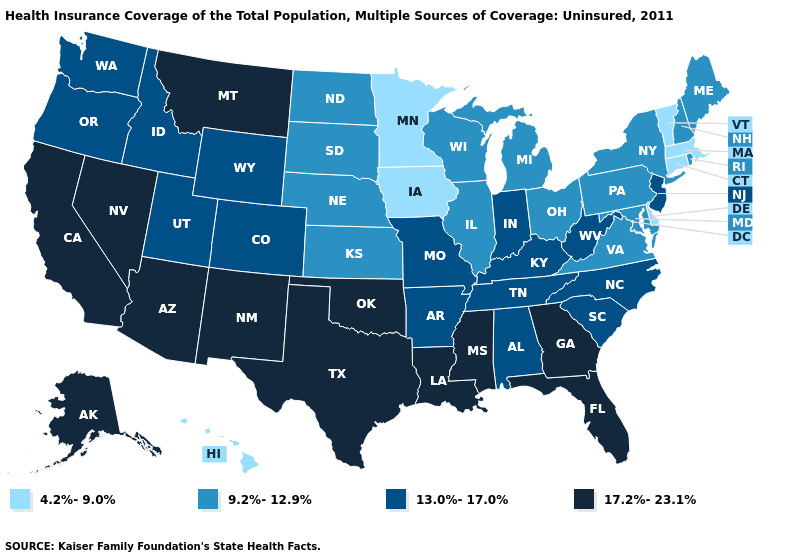Which states have the highest value in the USA?
Keep it brief. Alaska, Arizona, California, Florida, Georgia, Louisiana, Mississippi, Montana, Nevada, New Mexico, Oklahoma, Texas. Name the states that have a value in the range 4.2%-9.0%?
Keep it brief. Connecticut, Delaware, Hawaii, Iowa, Massachusetts, Minnesota, Vermont. Name the states that have a value in the range 9.2%-12.9%?
Quick response, please. Illinois, Kansas, Maine, Maryland, Michigan, Nebraska, New Hampshire, New York, North Dakota, Ohio, Pennsylvania, Rhode Island, South Dakota, Virginia, Wisconsin. Does Florida have the highest value in the USA?
Write a very short answer. Yes. Name the states that have a value in the range 13.0%-17.0%?
Answer briefly. Alabama, Arkansas, Colorado, Idaho, Indiana, Kentucky, Missouri, New Jersey, North Carolina, Oregon, South Carolina, Tennessee, Utah, Washington, West Virginia, Wyoming. Which states have the lowest value in the USA?
Concise answer only. Connecticut, Delaware, Hawaii, Iowa, Massachusetts, Minnesota, Vermont. Name the states that have a value in the range 17.2%-23.1%?
Keep it brief. Alaska, Arizona, California, Florida, Georgia, Louisiana, Mississippi, Montana, Nevada, New Mexico, Oklahoma, Texas. What is the value of Wyoming?
Short answer required. 13.0%-17.0%. Among the states that border Pennsylvania , which have the highest value?
Answer briefly. New Jersey, West Virginia. What is the value of Maine?
Quick response, please. 9.2%-12.9%. Name the states that have a value in the range 17.2%-23.1%?
Answer briefly. Alaska, Arizona, California, Florida, Georgia, Louisiana, Mississippi, Montana, Nevada, New Mexico, Oklahoma, Texas. Does Georgia have the highest value in the USA?
Be succinct. Yes. Does Maryland have the highest value in the USA?
Concise answer only. No. Does Mississippi have the highest value in the USA?
Answer briefly. Yes. How many symbols are there in the legend?
Give a very brief answer. 4. 